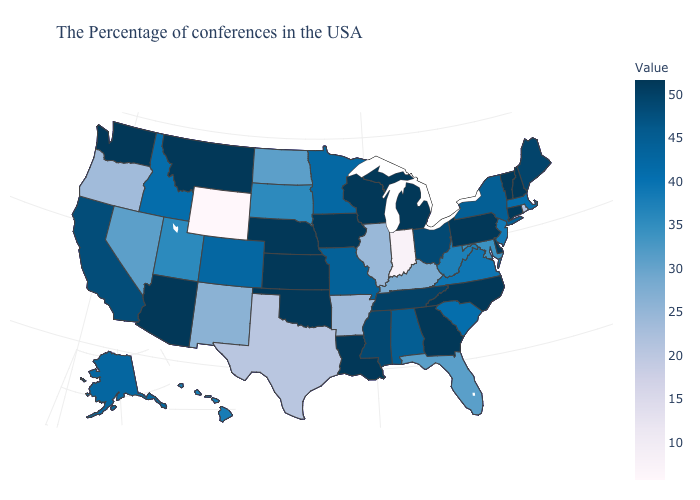Does Connecticut have the highest value in the USA?
Quick response, please. Yes. Which states have the lowest value in the USA?
Answer briefly. Wyoming. Among the states that border Louisiana , does Arkansas have the highest value?
Keep it brief. No. Among the states that border Illinois , does Iowa have the highest value?
Short answer required. Yes. Does the map have missing data?
Quick response, please. No. 